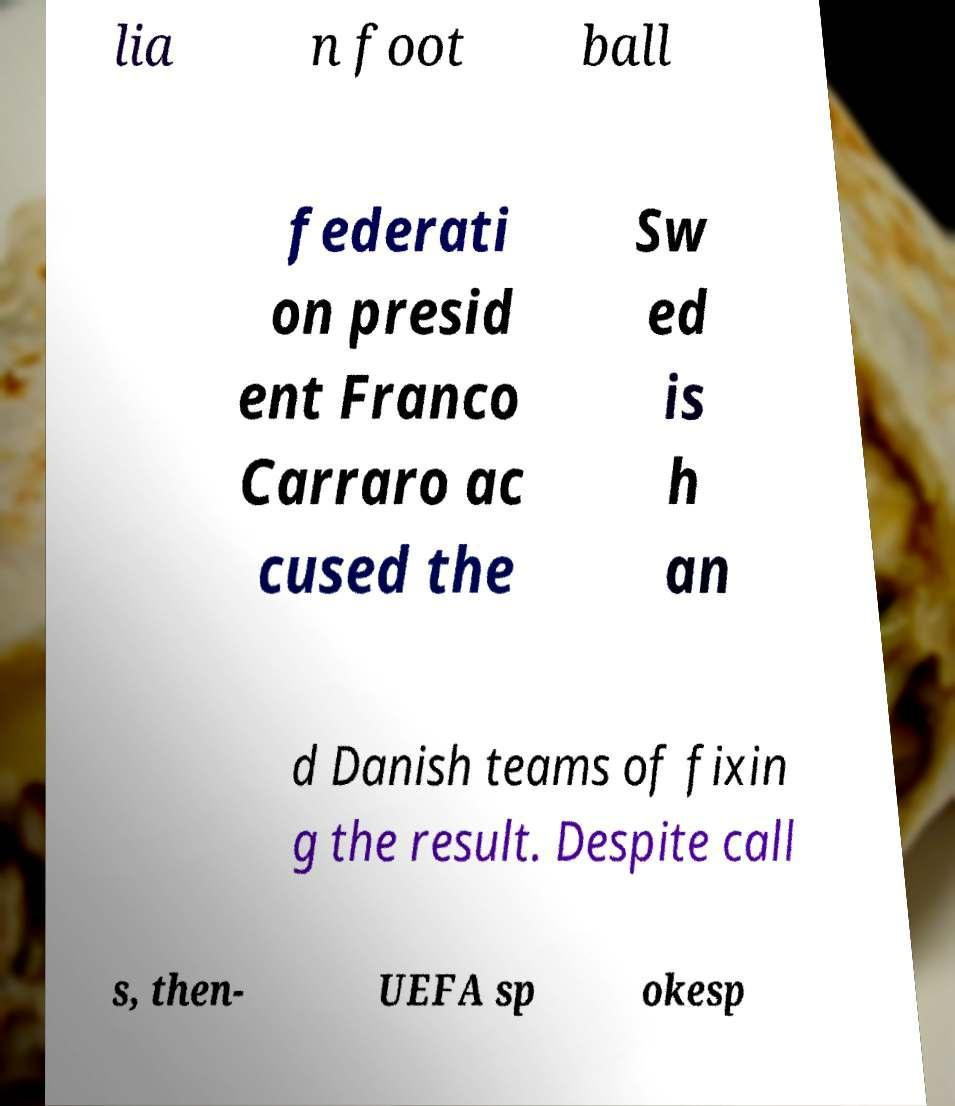Please read and relay the text visible in this image. What does it say? lia n foot ball federati on presid ent Franco Carraro ac cused the Sw ed is h an d Danish teams of fixin g the result. Despite call s, then- UEFA sp okesp 